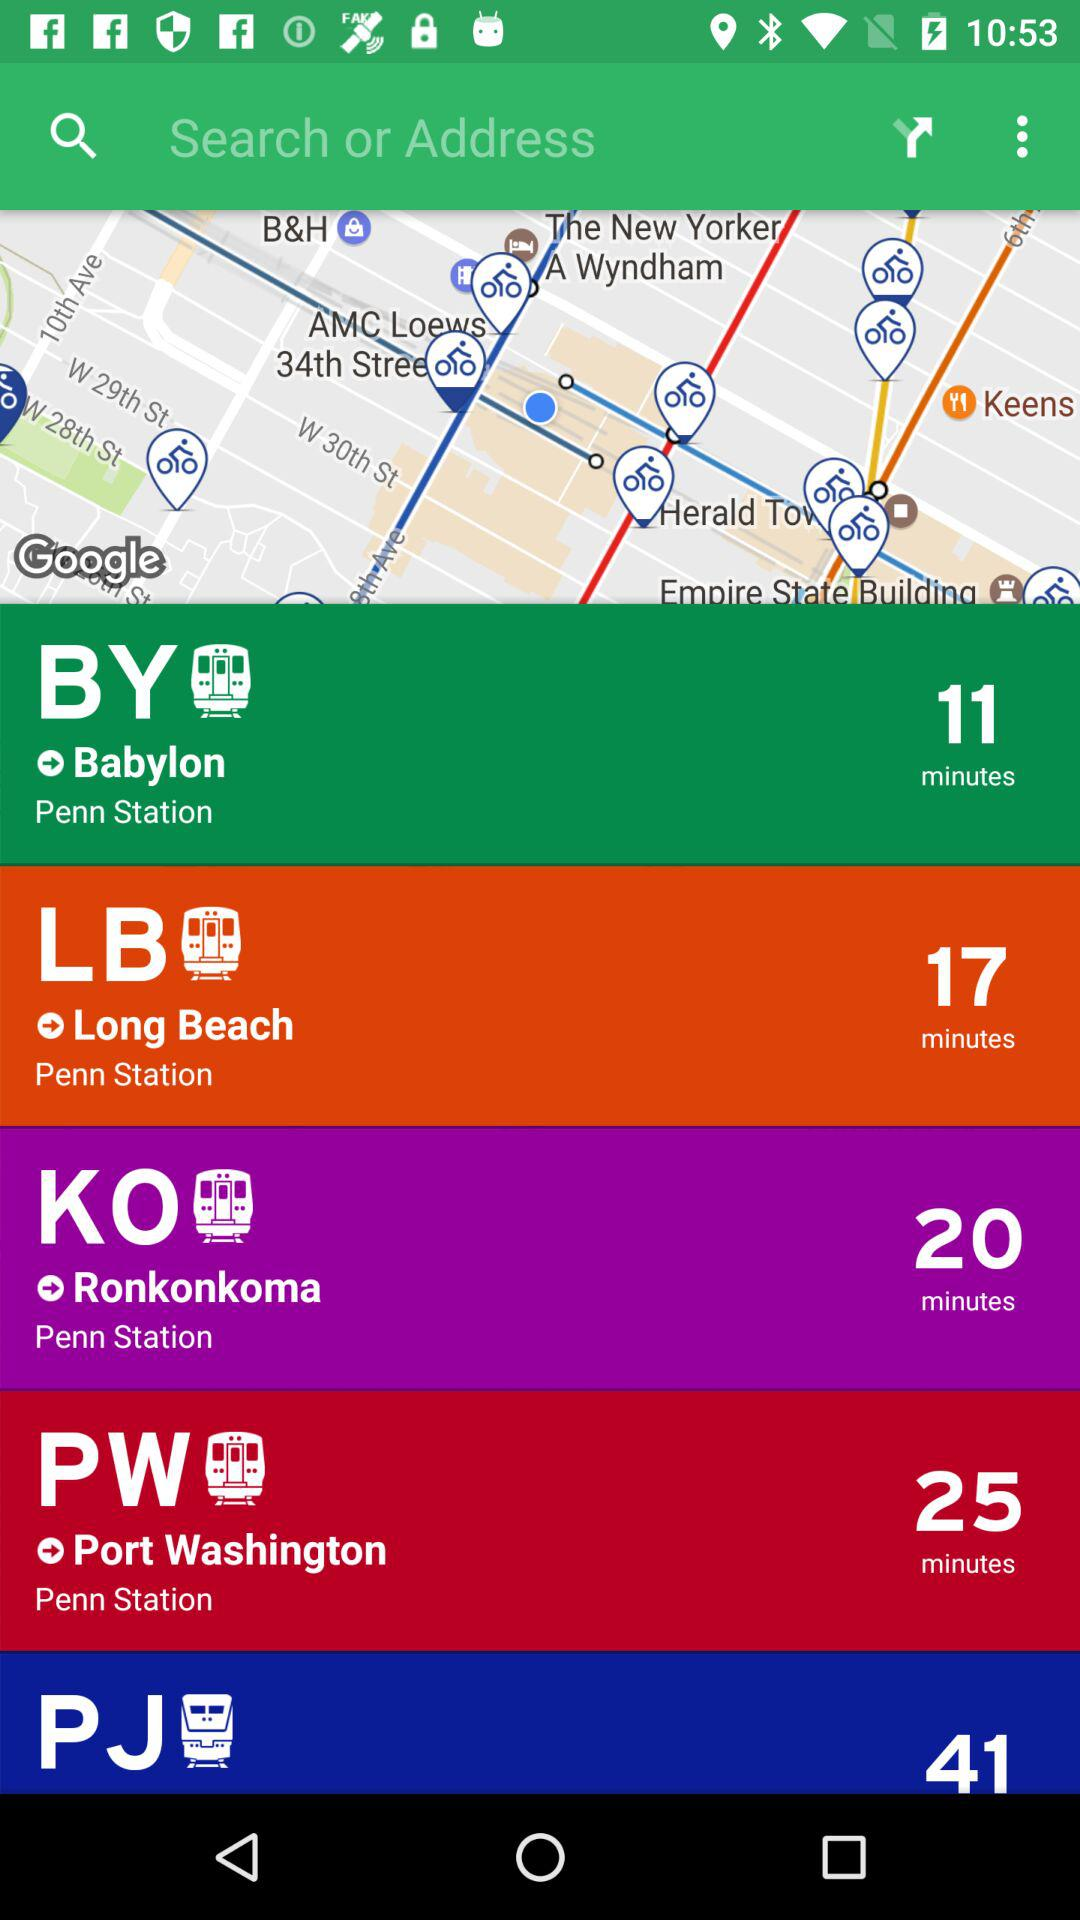From which common station does the journey start? The journey starts from "Penn Station". 